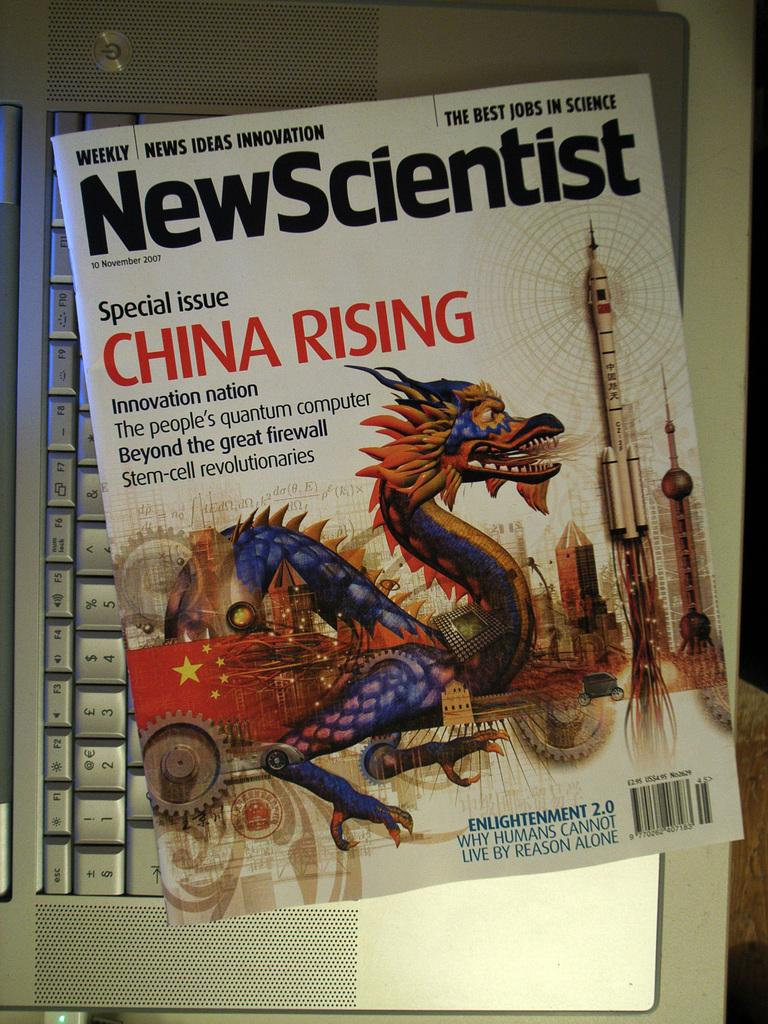<image>
Summarize the visual content of the image. Magazine cover showing a dragon titled New Scientist. 